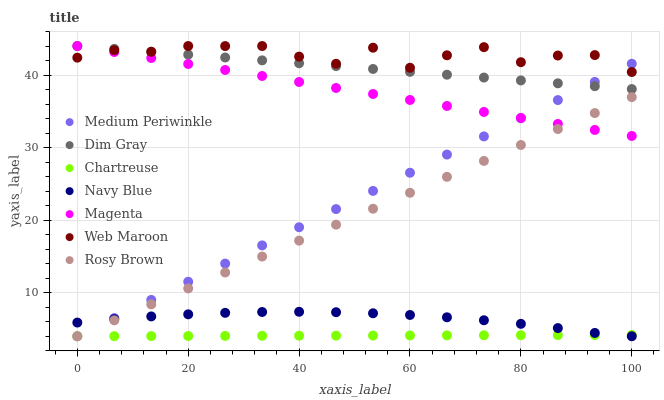Does Chartreuse have the minimum area under the curve?
Answer yes or no. Yes. Does Web Maroon have the maximum area under the curve?
Answer yes or no. Yes. Does Navy Blue have the minimum area under the curve?
Answer yes or no. No. Does Navy Blue have the maximum area under the curve?
Answer yes or no. No. Is Chartreuse the smoothest?
Answer yes or no. Yes. Is Web Maroon the roughest?
Answer yes or no. Yes. Is Navy Blue the smoothest?
Answer yes or no. No. Is Navy Blue the roughest?
Answer yes or no. No. Does Navy Blue have the lowest value?
Answer yes or no. Yes. Does Web Maroon have the lowest value?
Answer yes or no. No. Does Magenta have the highest value?
Answer yes or no. Yes. Does Navy Blue have the highest value?
Answer yes or no. No. Is Navy Blue less than Magenta?
Answer yes or no. Yes. Is Dim Gray greater than Rosy Brown?
Answer yes or no. Yes. Does Chartreuse intersect Rosy Brown?
Answer yes or no. Yes. Is Chartreuse less than Rosy Brown?
Answer yes or no. No. Is Chartreuse greater than Rosy Brown?
Answer yes or no. No. Does Navy Blue intersect Magenta?
Answer yes or no. No. 